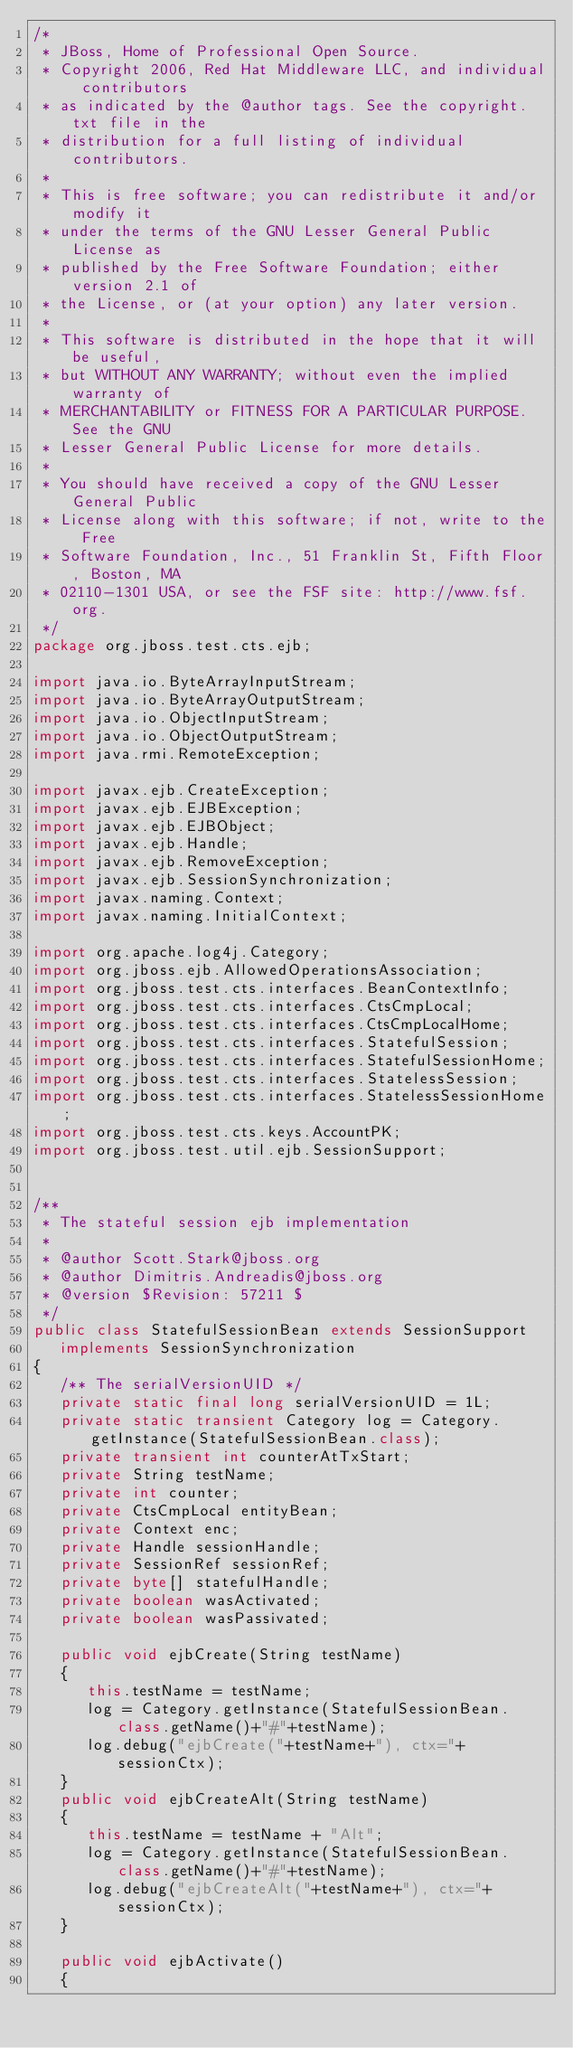<code> <loc_0><loc_0><loc_500><loc_500><_Java_>/*
 * JBoss, Home of Professional Open Source.
 * Copyright 2006, Red Hat Middleware LLC, and individual contributors
 * as indicated by the @author tags. See the copyright.txt file in the
 * distribution for a full listing of individual contributors.
 *
 * This is free software; you can redistribute it and/or modify it
 * under the terms of the GNU Lesser General Public License as
 * published by the Free Software Foundation; either version 2.1 of
 * the License, or (at your option) any later version.
 *
 * This software is distributed in the hope that it will be useful,
 * but WITHOUT ANY WARRANTY; without even the implied warranty of
 * MERCHANTABILITY or FITNESS FOR A PARTICULAR PURPOSE. See the GNU
 * Lesser General Public License for more details.
 *
 * You should have received a copy of the GNU Lesser General Public
 * License along with this software; if not, write to the Free
 * Software Foundation, Inc., 51 Franklin St, Fifth Floor, Boston, MA
 * 02110-1301 USA, or see the FSF site: http://www.fsf.org.
 */
package org.jboss.test.cts.ejb;

import java.io.ByteArrayInputStream;
import java.io.ByteArrayOutputStream;
import java.io.ObjectInputStream;
import java.io.ObjectOutputStream;
import java.rmi.RemoteException;

import javax.ejb.CreateException;
import javax.ejb.EJBException;
import javax.ejb.EJBObject;
import javax.ejb.Handle;
import javax.ejb.RemoveException;
import javax.ejb.SessionSynchronization;
import javax.naming.Context;
import javax.naming.InitialContext;

import org.apache.log4j.Category;
import org.jboss.ejb.AllowedOperationsAssociation;
import org.jboss.test.cts.interfaces.BeanContextInfo;
import org.jboss.test.cts.interfaces.CtsCmpLocal;
import org.jboss.test.cts.interfaces.CtsCmpLocalHome;
import org.jboss.test.cts.interfaces.StatefulSession;
import org.jboss.test.cts.interfaces.StatefulSessionHome;
import org.jboss.test.cts.interfaces.StatelessSession;
import org.jboss.test.cts.interfaces.StatelessSessionHome;
import org.jboss.test.cts.keys.AccountPK;
import org.jboss.test.util.ejb.SessionSupport;


/** 
 * The stateful session ejb implementation
 *
 * @author Scott.Stark@jboss.org
 * @author Dimitris.Andreadis@jboss.org
 * @version $Revision: 57211 $
 */
public class StatefulSessionBean extends SessionSupport
   implements SessionSynchronization
{
   /** The serialVersionUID */
   private static final long serialVersionUID = 1L;
   private static transient Category log = Category.getInstance(StatefulSessionBean.class);
   private transient int counterAtTxStart;
   private String testName;
   private int counter;
   private CtsCmpLocal entityBean;
   private Context enc;
   private Handle sessionHandle;
   private SessionRef sessionRef;
   private byte[] statefulHandle;
   private boolean wasActivated;
   private boolean wasPassivated;

   public void ejbCreate(String testName)
   {
      this.testName = testName;
      log = Category.getInstance(StatefulSessionBean.class.getName()+"#"+testName);
      log.debug("ejbCreate("+testName+"), ctx="+sessionCtx);
   }
   public void ejbCreateAlt(String testName)
   {
      this.testName = testName + "Alt";
      log = Category.getInstance(StatefulSessionBean.class.getName()+"#"+testName);
      log.debug("ejbCreateAlt("+testName+"), ctx="+sessionCtx);
   }

   public void ejbActivate()
   {</code> 